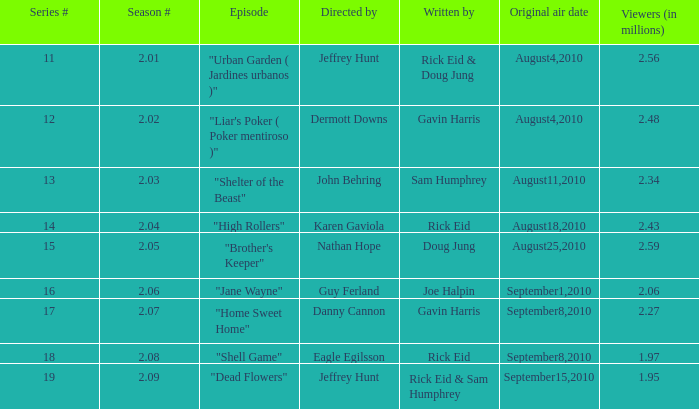If the amount of viewers is 2.48 million, what is the original air date? August4,2010. 